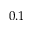<formula> <loc_0><loc_0><loc_500><loc_500>0 . 1</formula> 